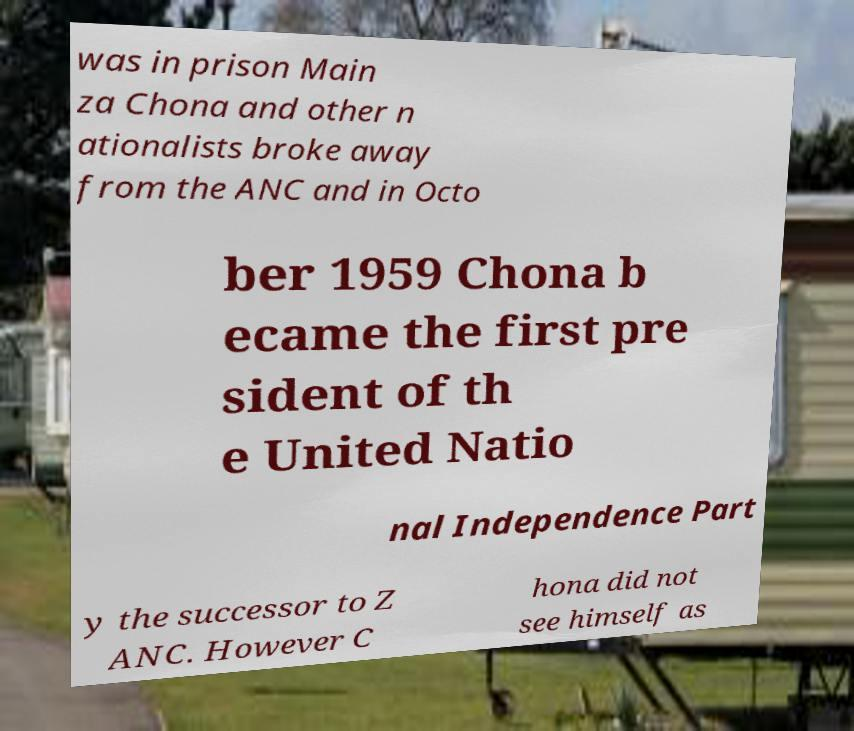Please read and relay the text visible in this image. What does it say? was in prison Main za Chona and other n ationalists broke away from the ANC and in Octo ber 1959 Chona b ecame the first pre sident of th e United Natio nal Independence Part y the successor to Z ANC. However C hona did not see himself as 